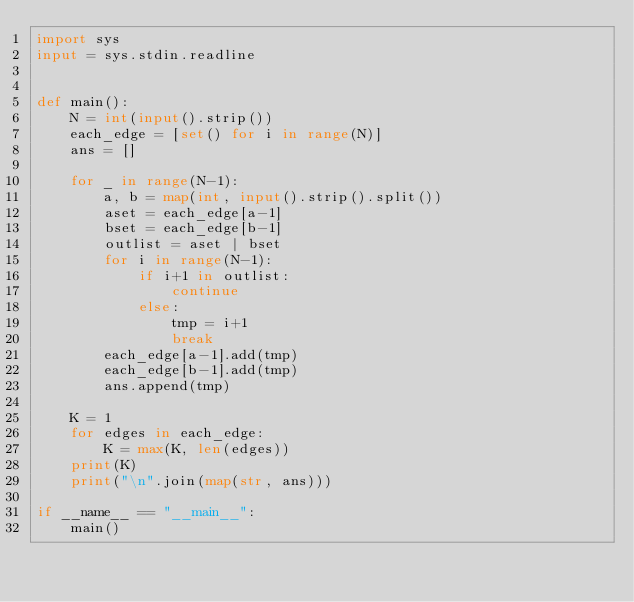<code> <loc_0><loc_0><loc_500><loc_500><_Python_>import sys
input = sys.stdin.readline


def main():
    N = int(input().strip())
    each_edge = [set() for i in range(N)]
    ans = []

    for _ in range(N-1):
        a, b = map(int, input().strip().split())
        aset = each_edge[a-1]
        bset = each_edge[b-1]
        outlist = aset | bset
        for i in range(N-1):
            if i+1 in outlist:
                continue
            else:
                tmp = i+1
                break
        each_edge[a-1].add(tmp)
        each_edge[b-1].add(tmp)
        ans.append(tmp)

    K = 1
    for edges in each_edge:
        K = max(K, len(edges))
    print(K)
    print("\n".join(map(str, ans)))

if __name__ == "__main__":
    main()
</code> 